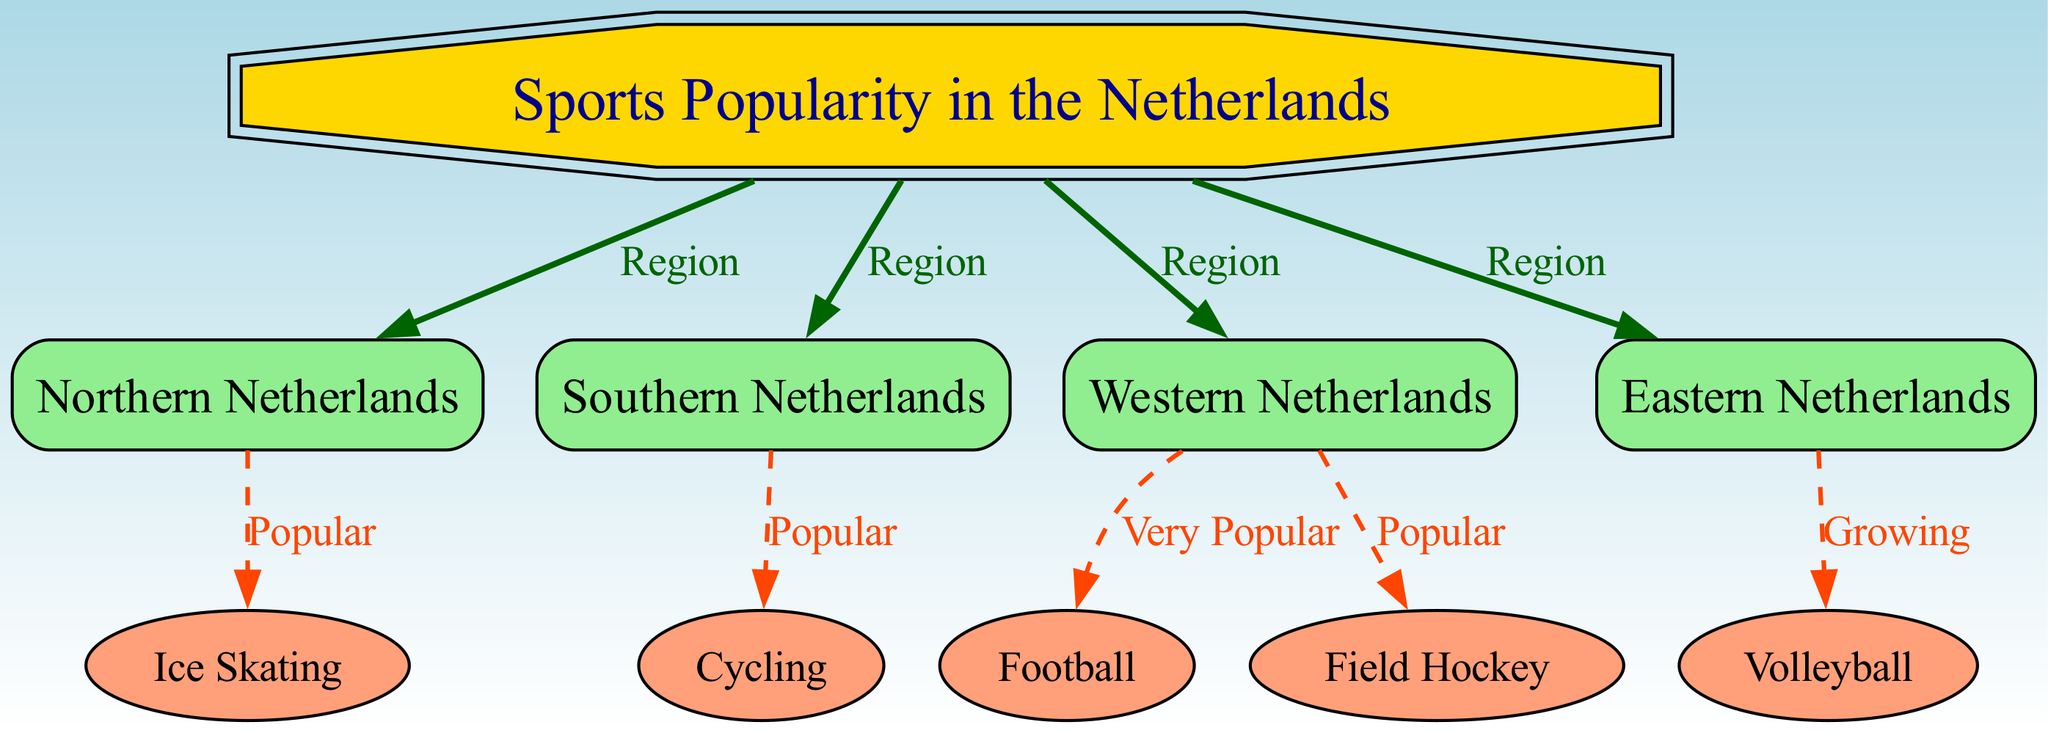What is the main title of the diagram? The main title is the label of the root node, which describes the overall theme of the diagram. Here, the label is "Sports Popularity in the Netherlands."
Answer: Sports Popularity in the Netherlands How many regions are represented in the diagram? To find the number of regions, we count the nodes directly connected to the root node where "Region" is indicated as the label for the edges. There are four regions: Northern Netherlands, Southern Netherlands, Western Netherlands, and Eastern Netherlands.
Answer: 4 Which sport is identified as "Very Popular" in the Western Netherlands? In the diagram, there is a node connected to the Western Netherlands that describes football as "Very Popular." We find the specific node by tracing the edge labeled "Very Popular."
Answer: Football What sport is new and described as "Growing" in the Eastern Netherlands? The sport associated with the Eastern Netherlands is found by following the relevant node connected to it. The label on the edge indicates that volleyball is described as "Growing."
Answer: Volleyball Which sport is linked to the Northern Netherlands? To identify the sport linked to the Northern Netherlands, we check the connection shown on the diagram. It corresponds to the node labeled "Ice Skating."
Answer: Ice Skating How many different sports are represented in this diagram? We can obtain the number of sports by counting the nodes that represent individual sports, which are connected to the different regional nodes in the diagram. There are five distinct sports depicted: Ice Skating, Cycling, Football, Field Hockey, and Volleyball.
Answer: 5 Which region is associated with the sport of cycling? To determine the region for cycling, we look at the edge connecting the Southern Netherlands to the cycling node, indicating that cycling is prominent there.
Answer: Southern Netherlands What color are the nodes representing the regions in the diagram? By examining the diagram's visual properties, we see that the nodes representing the regions (Northern, Southern, Western, and Eastern Netherlands) are colored light green.
Answer: Light Green What type of edge connects the nodes for regions to the root node? The connection type for regions to the root is indicated through labeled edges that specify a relationship marked as "Region." This can be verified by checking all edges linking the nodes.
Answer: Region 